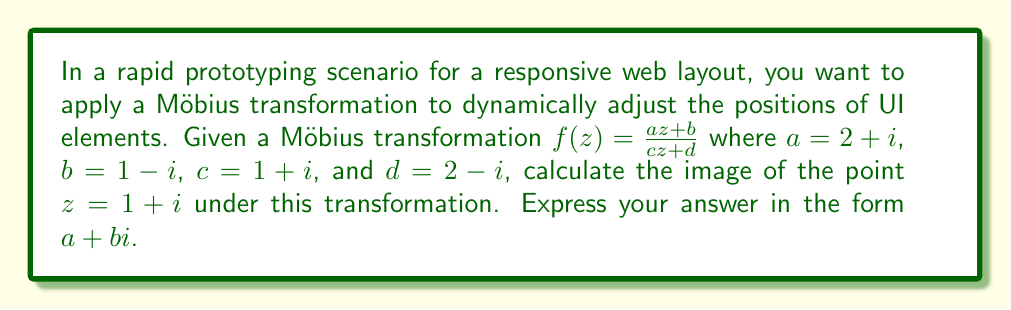Teach me how to tackle this problem. To solve this problem, we'll follow these steps:

1) We have the Möbius transformation $f(z) = \frac{az + b}{cz + d}$ with:
   $a = 2+i$
   $b = 1-i$
   $c = 1+i$
   $d = 2-i$
   $z = 1+i$

2) Let's substitute these values into the formula:

   $$f(1+i) = \frac{(2+i)(1+i) + (1-i)}{(1+i)(1+i) + (2-i)}$$

3) Let's simplify the numerator first:
   $(2+i)(1+i) = 2 + 2i + i + i^2 = 2 + 2i + i - 1 = 1 + 3i$
   So, numerator = $(1 + 3i) + (1-i) = 2 + 2i$

4) Now the denominator:
   $(1+i)(1+i) = 1 + 2i + i^2 = 1 + 2i - 1 = 2i$
   So, denominator = $2i + (2-i) = 2 + i$

5) Our fraction now looks like:

   $$f(1+i) = \frac{2 + 2i}{2 + i}$$

6) To divide complex numbers, we multiply both numerator and denominator by the complex conjugate of the denominator:

   $$f(1+i) = \frac{(2 + 2i)(2 - i)}{(2 + i)(2 - i)} = \frac{4 - 2i + 4i + 2i^2}{4 - i^2} = \frac{2 + 2i}{5}$$

7) Separating real and imaginary parts:

   $$f(1+i) = \frac{2}{5} + \frac{2}{5}i$$
Answer: $\frac{2}{5} + \frac{2}{5}i$ 